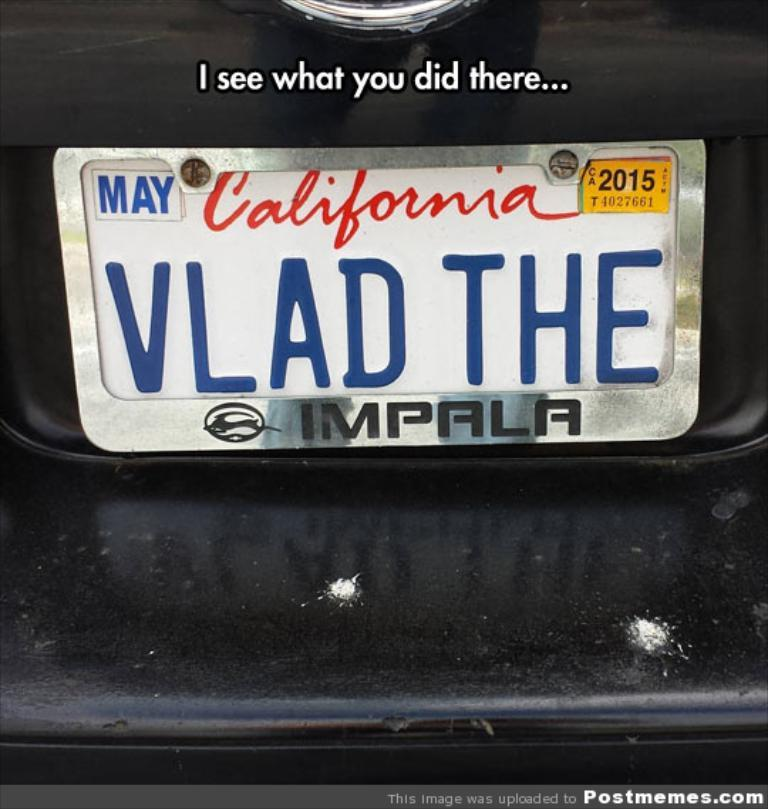<image>
Provide a brief description of the given image. A meme image showing a license plate with a pun Vlad the Impala 